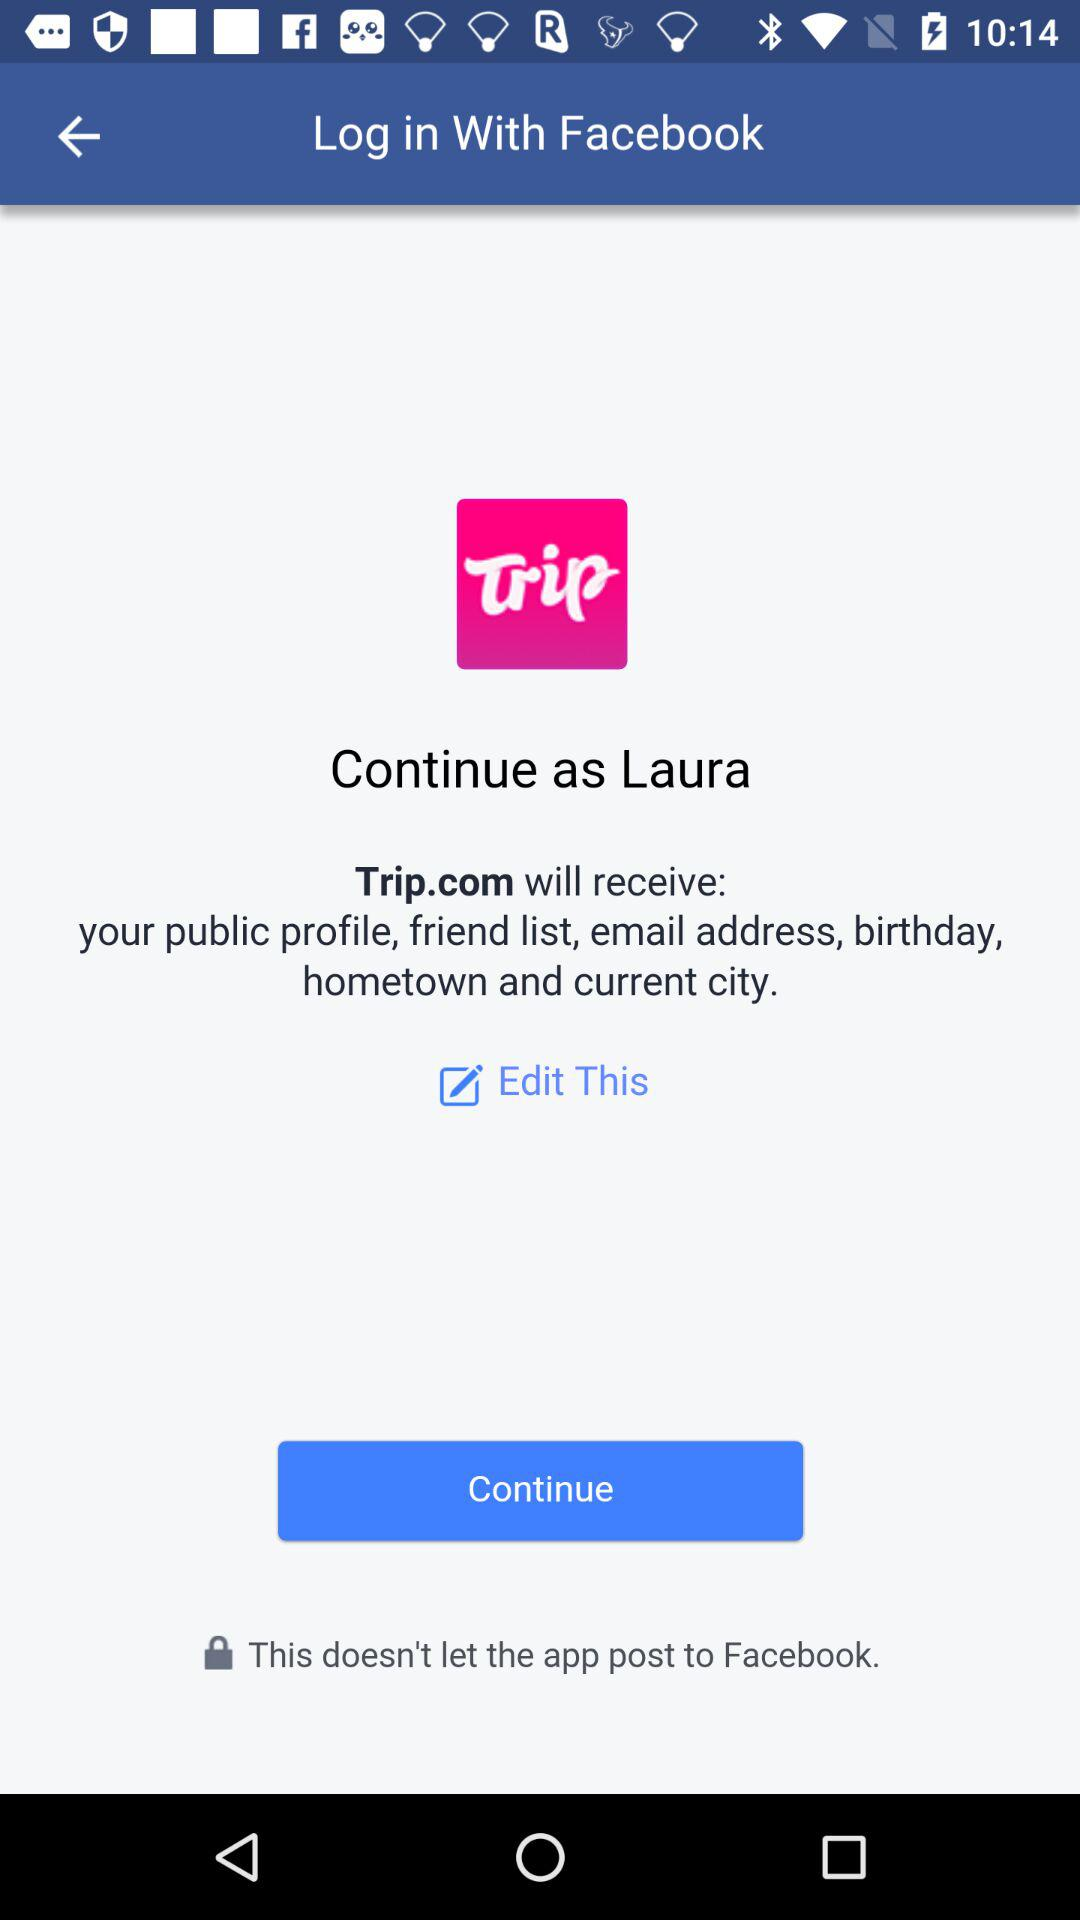Who developed the "Trip" app?
When the provided information is insufficient, respond with <no answer>. <no answer> 